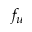Convert formula to latex. <formula><loc_0><loc_0><loc_500><loc_500>f _ { u }</formula> 